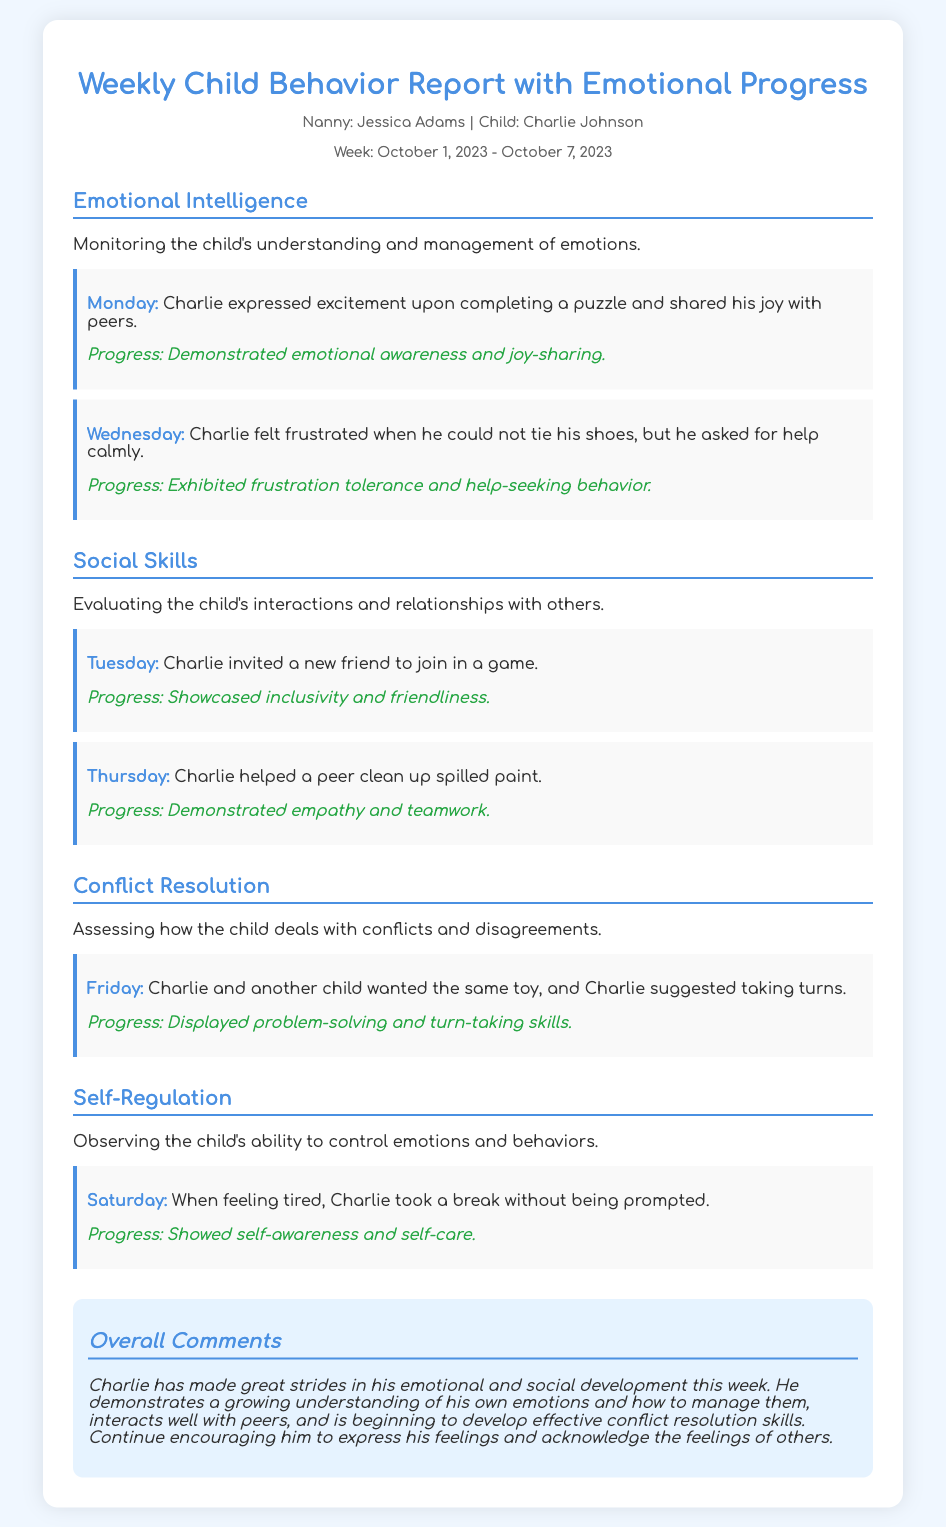What is the child's name? The child's name is mentioned in the document as Charlie Johnson.
Answer: Charlie Johnson Who is the nanny? The nanny's name is provided in the meta section of the document.
Answer: Jessica Adams What week does this report cover? The report covers the specified time frame from October 1, 2023, to October 7, 2023.
Answer: October 1, 2023 - October 7, 2023 On which day did Charlie express excitement? The document specifies that Charlie expressed excitement on Monday upon completing a puzzle.
Answer: Monday What progress did Charlie show on Tuesday? The report indicates that on Tuesday, Charlie showcased inclusivity and friendliness.
Answer: Inclusivity and friendliness How did Charlie handle his frustration on Wednesday? The document mentions that Charlie asked for help calmly when he felt frustrated.
Answer: Asked for help calmly What action did Charlie take when feeling tired on Saturday? The document states that Charlie took a break without being prompted.
Answer: Took a break What conflict resolution skill did Charlie demonstrate on Friday? The report notes that Charlie suggested taking turns when he and another child wanted the same toy.
Answer: Taking turns What overall progress did Charlie make this week? The overall comments highlight Charlie's strides in emotional and social development as a notable progress this week.
Answer: Emotional and social development 